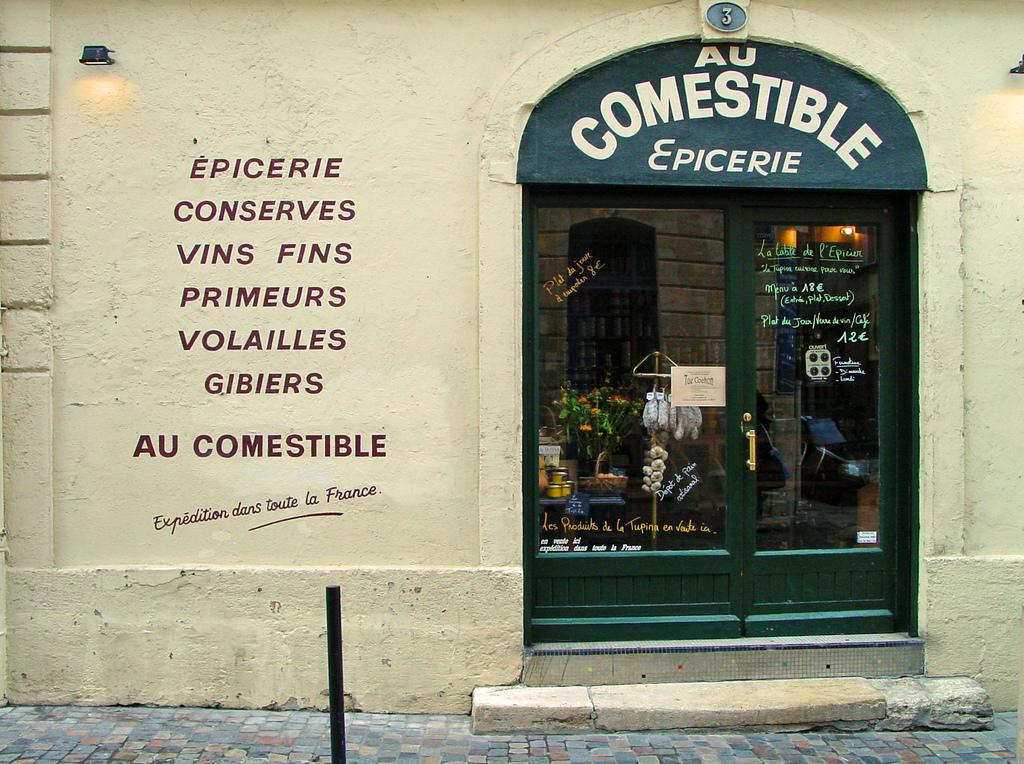What type of structure is visible in the image? There is a building in the image. What can be seen on the wall of the building? There is text on the wall of the building. What type of entrance is present on the building? There is a glass door on the building. What is written on the top of the door? There is text on the top of the door. What is located on the path in front of the building? There is a rod on the path in front of the building. How many crackers are visible on the roof of the building in the image? There are no crackers visible on the roof of the building in the image. Can you see an airplane flying over the building in the image? There is no airplane visible in the image. 